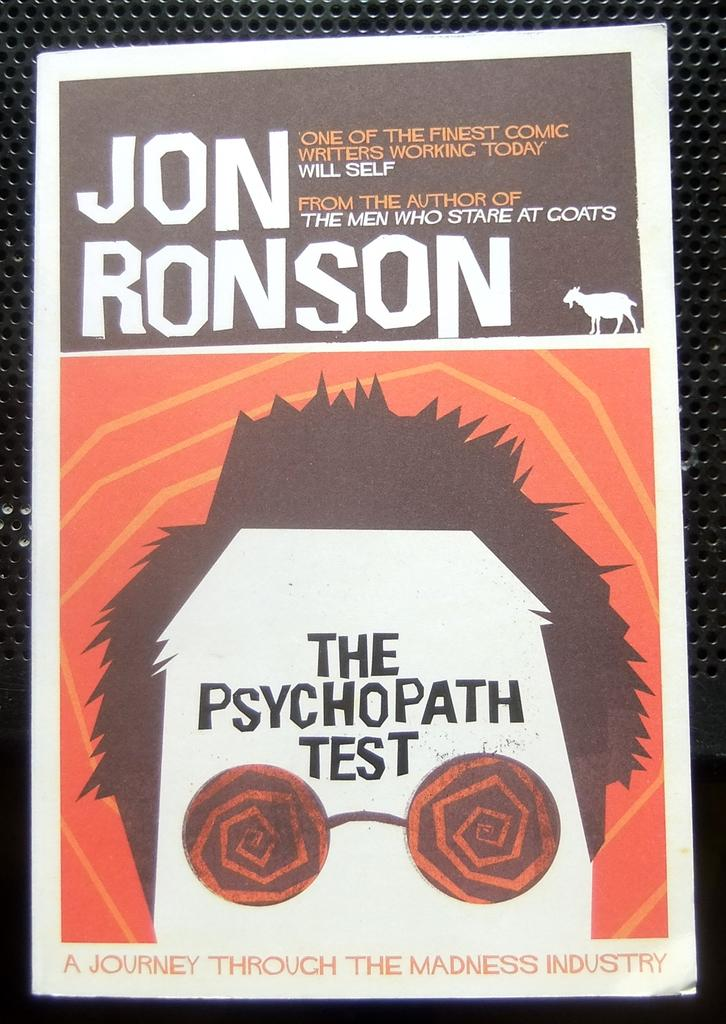<image>
Offer a succinct explanation of the picture presented. An advertisement for Jon Ronson's The Psychopath Test. 